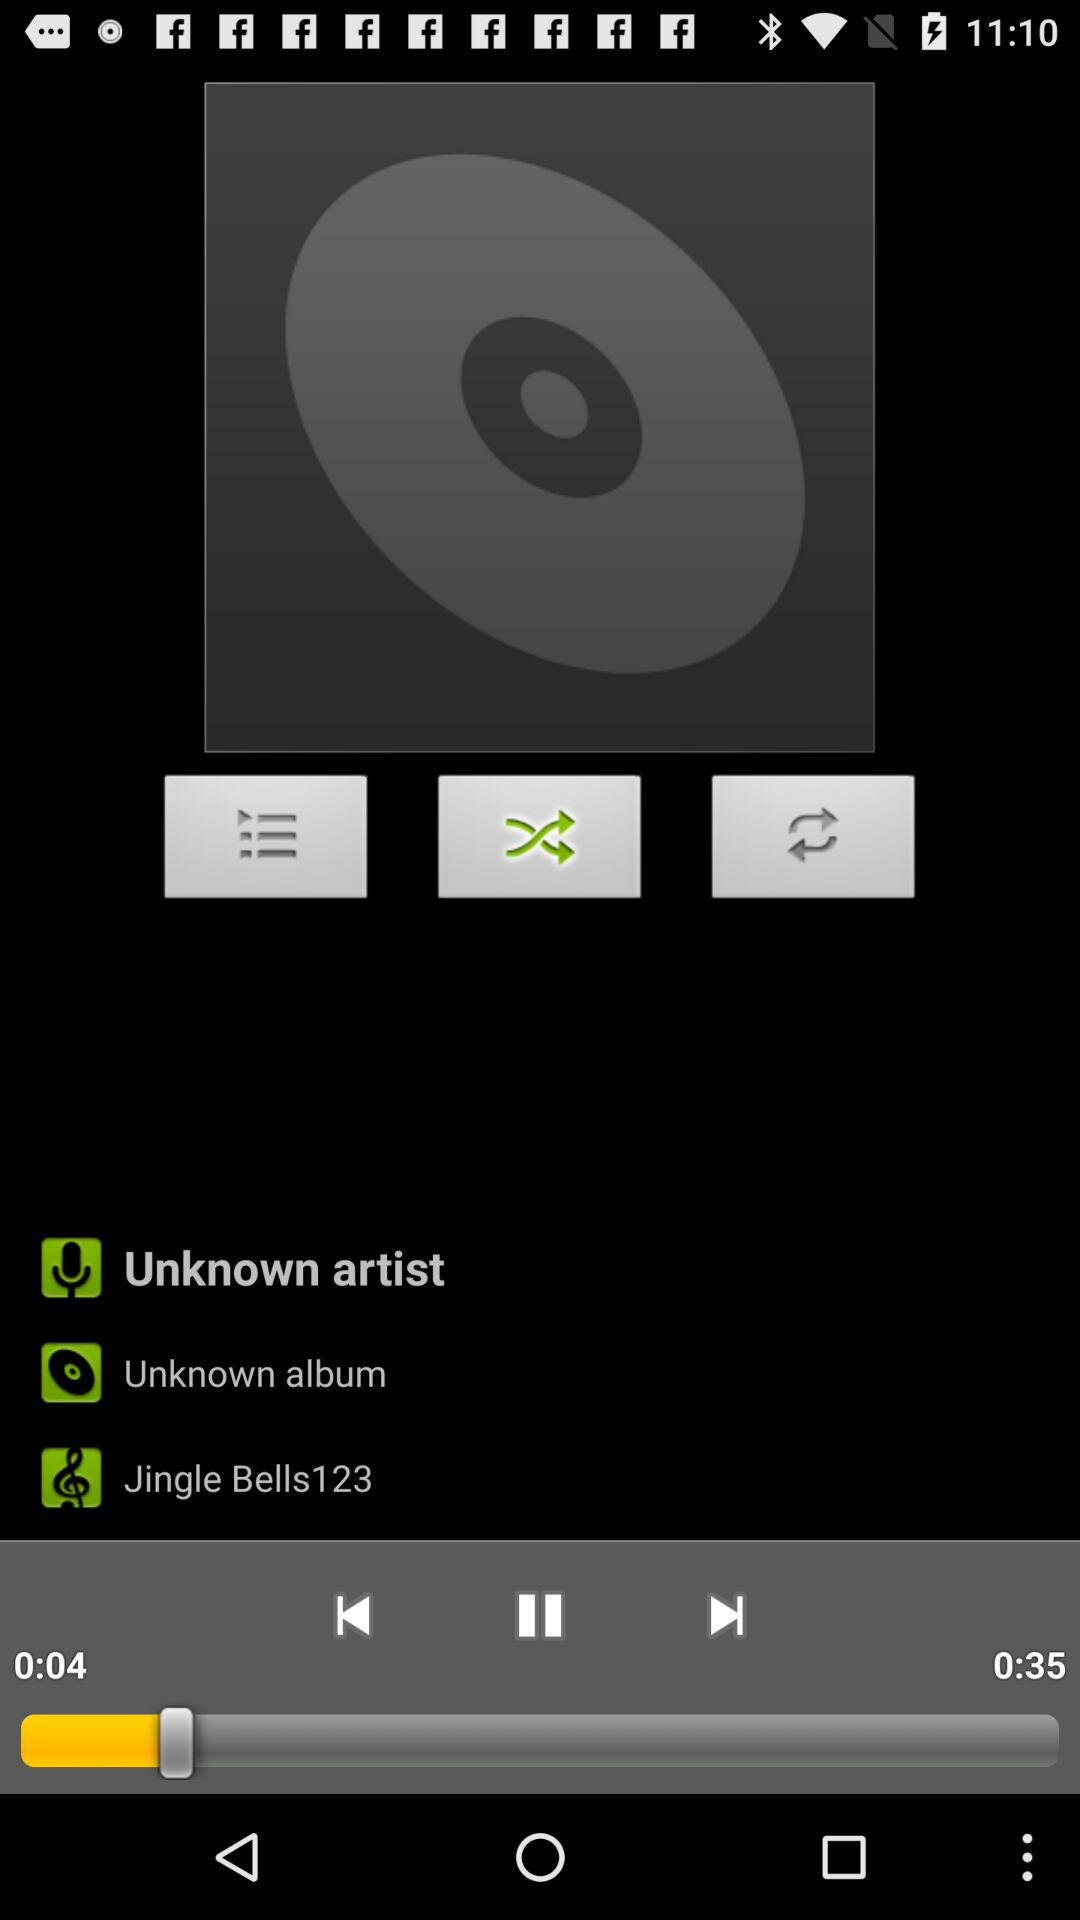What is the album name? The album name is "Unknown album". 